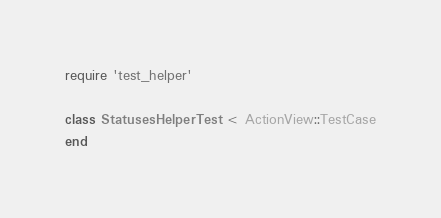Convert code to text. <code><loc_0><loc_0><loc_500><loc_500><_Ruby_>require 'test_helper'

class StatusesHelperTest < ActionView::TestCase
end
</code> 